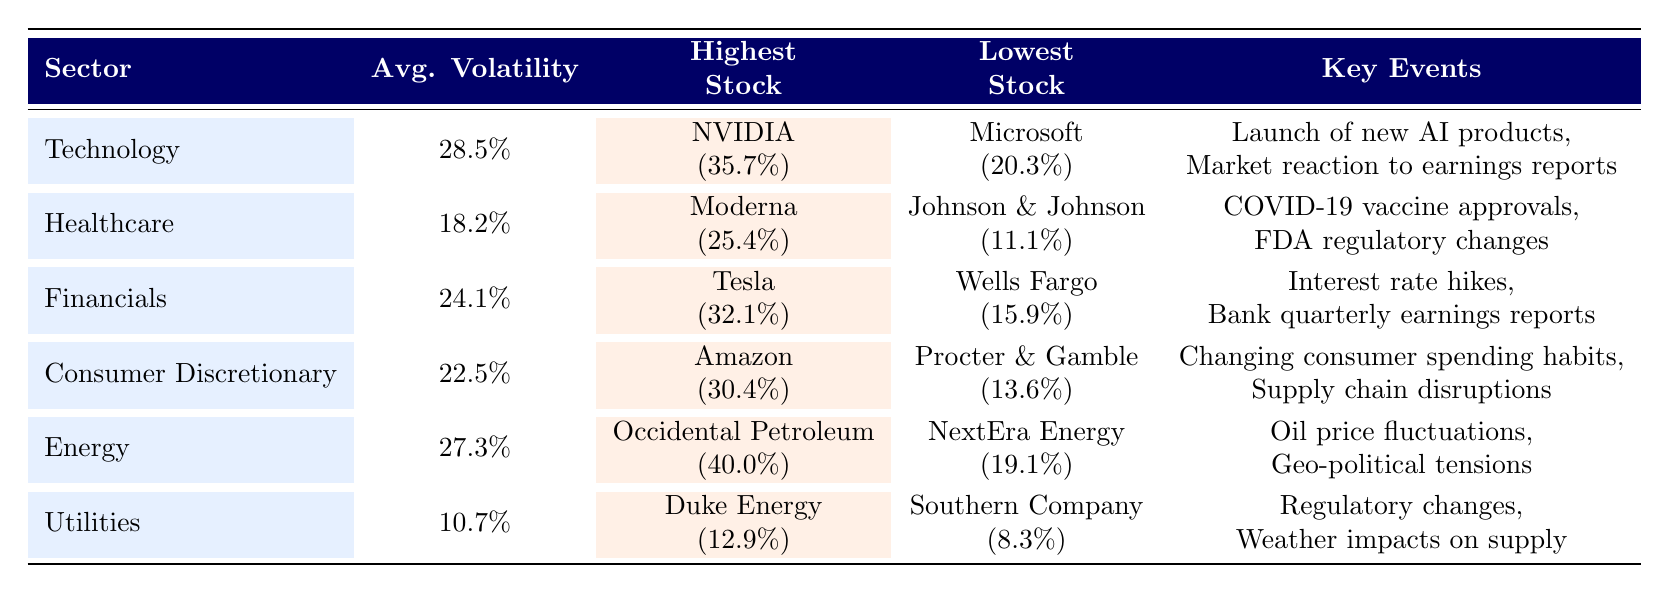What is the average volatility of the Healthcare sector? The table shows that the average volatility for the Healthcare sector is listed directly under the "Avg. Volatility" column. According to the table, it reads 18.2%.
Answer: 18.2% Which sector has the highest average volatility? By looking at the "Avg. Volatility" column, the Technology sector has the highest average volatility at 28.5%, demonstrating that it experiences more fluctuations compared to other sectors listed.
Answer: Technology What is the lowest recorded volatility in the Financials sector? The table indicates that the lowest stock within the Financials sector is Wells Fargo & Company, with a recorded volatility of 15.9%. This value is found directly in the "Lowest Stock" column of the Financials row.
Answer: 15.9% How does the average volatility of the Utilities sector compare to that of the Consumer Discretionary sector? The Utilities sector has an average volatility of 10.7%, while the Consumer Discretionary sector has an average volatility of 22.5%. When comparing these two figures, the Consumer Discretionary sector has significantly higher volatility than the Utilities sector.
Answer: Consumer Discretionary has higher volatility If you combine the average volatility of Technology and Energy sectors, what is the total? The average volatility for the Technology sector is 28.5% and for the Energy sector, it is 27.3%. Adding these two values together gives 28.5% + 27.3% = 55.8%.
Answer: 55.8% Is it true that Moderna has the highest volatility in the Healthcare sector? According to the table, Moderna has a recorded volatility of 25.4%, which is higher than Johnson & Johnson at 11.1%. Therefore, it is true that Moderna has the highest volatility in the Healthcare sector.
Answer: Yes Which sector has a volatility that is lower than 20%? The Utilities sector has an average volatility of 10.7%, and that is the only sector listed in the table with a lower average volatility than 20%, based on the information provided across all sectors in the table.
Answer: Utilities What is the difference in average volatility between the Technology and Healthcare sectors? The average volatility for Technology is 28.5% and for Healthcare, it is 18.2%. Therefore, the difference is calculated as follows: 28.5% - 18.2% = 10.3%.
Answer: 10.3% 